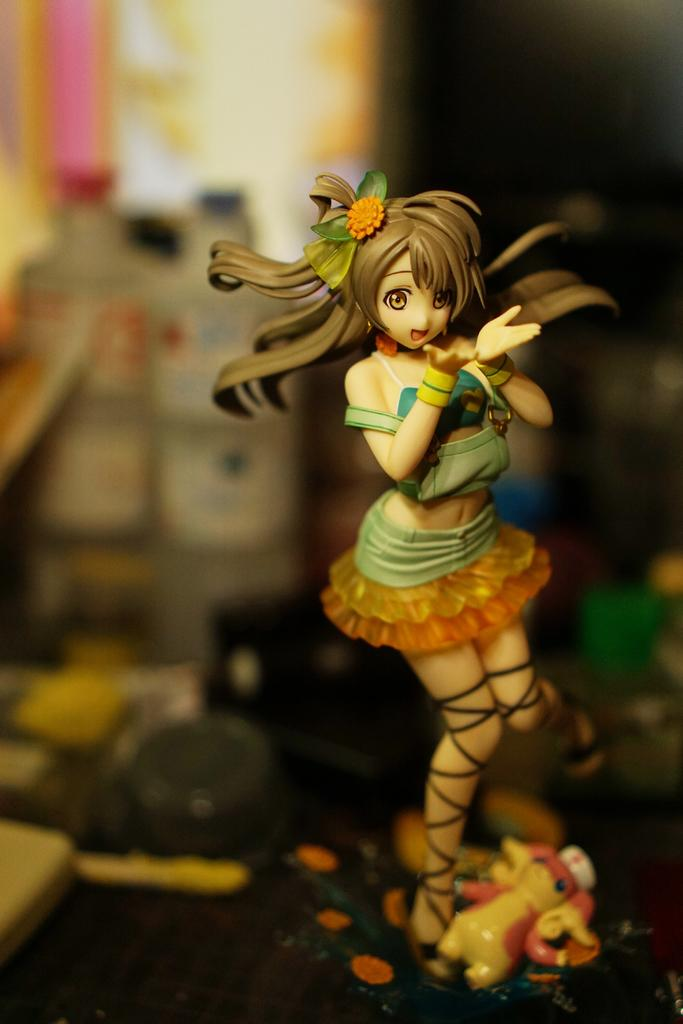What is the main subject of the image? There is a doll in the image. What can be seen in the background of the image? There are bottles in the background of the image. What other objects are present at the bottom of the image? There are toys at the bottom of the image. What type of punishment is being administered to the doll in the image? There is no punishment being administered to the doll in the image; it is simply a doll sitting in the scene. 